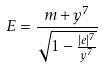<formula> <loc_0><loc_0><loc_500><loc_500>E = \frac { m + y ^ { 7 } } { \sqrt { 1 - \frac { | e | ^ { 7 } } { y ^ { 7 } } } }</formula> 